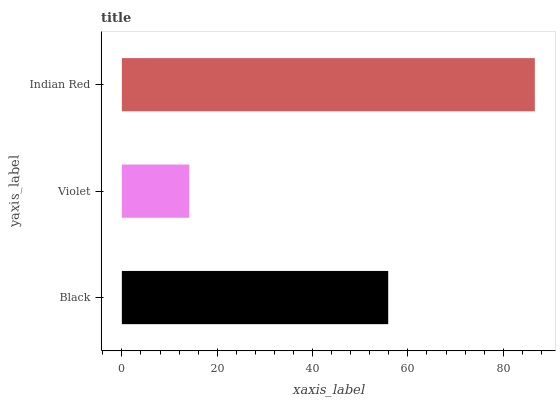Is Violet the minimum?
Answer yes or no. Yes. Is Indian Red the maximum?
Answer yes or no. Yes. Is Indian Red the minimum?
Answer yes or no. No. Is Violet the maximum?
Answer yes or no. No. Is Indian Red greater than Violet?
Answer yes or no. Yes. Is Violet less than Indian Red?
Answer yes or no. Yes. Is Violet greater than Indian Red?
Answer yes or no. No. Is Indian Red less than Violet?
Answer yes or no. No. Is Black the high median?
Answer yes or no. Yes. Is Black the low median?
Answer yes or no. Yes. Is Violet the high median?
Answer yes or no. No. Is Violet the low median?
Answer yes or no. No. 